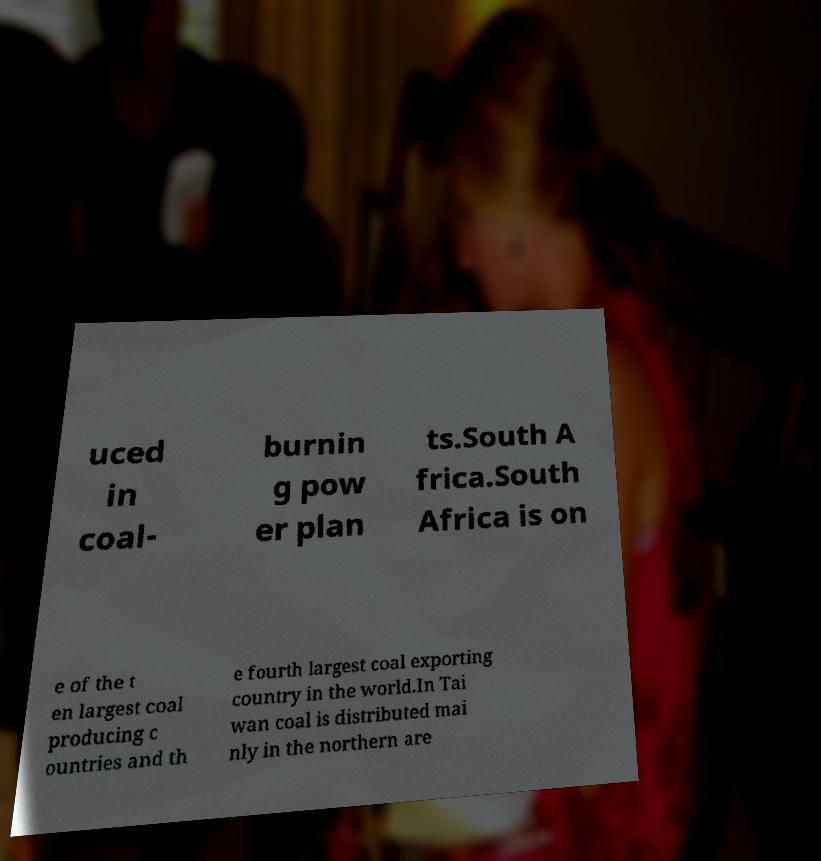There's text embedded in this image that I need extracted. Can you transcribe it verbatim? uced in coal- burnin g pow er plan ts.South A frica.South Africa is on e of the t en largest coal producing c ountries and th e fourth largest coal exporting country in the world.In Tai wan coal is distributed mai nly in the northern are 